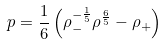Convert formula to latex. <formula><loc_0><loc_0><loc_500><loc_500>p = \frac { 1 } { 6 } \left ( \rho _ { - } ^ { - \frac { 1 } { 5 } } \rho ^ { \frac { 6 } { 5 } } - \rho _ { + } \right )</formula> 